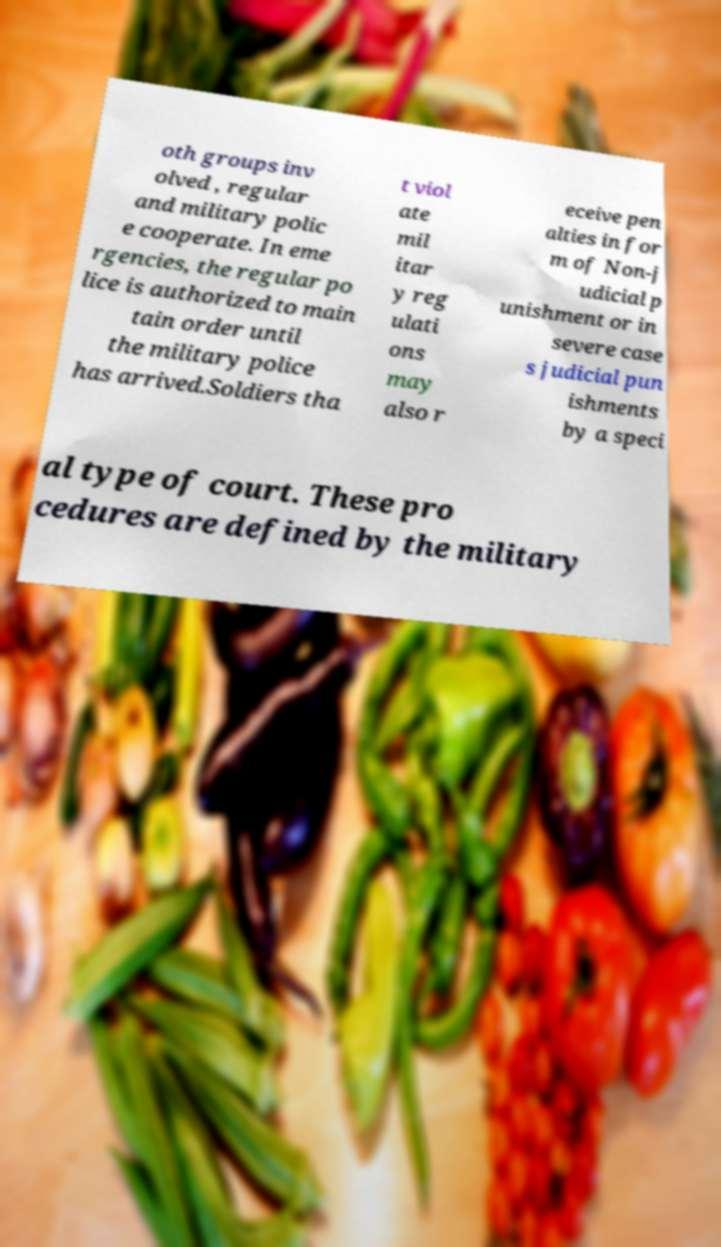What messages or text are displayed in this image? I need them in a readable, typed format. oth groups inv olved , regular and military polic e cooperate. In eme rgencies, the regular po lice is authorized to main tain order until the military police has arrived.Soldiers tha t viol ate mil itar y reg ulati ons may also r eceive pen alties in for m of Non-j udicial p unishment or in severe case s judicial pun ishments by a speci al type of court. These pro cedures are defined by the military 